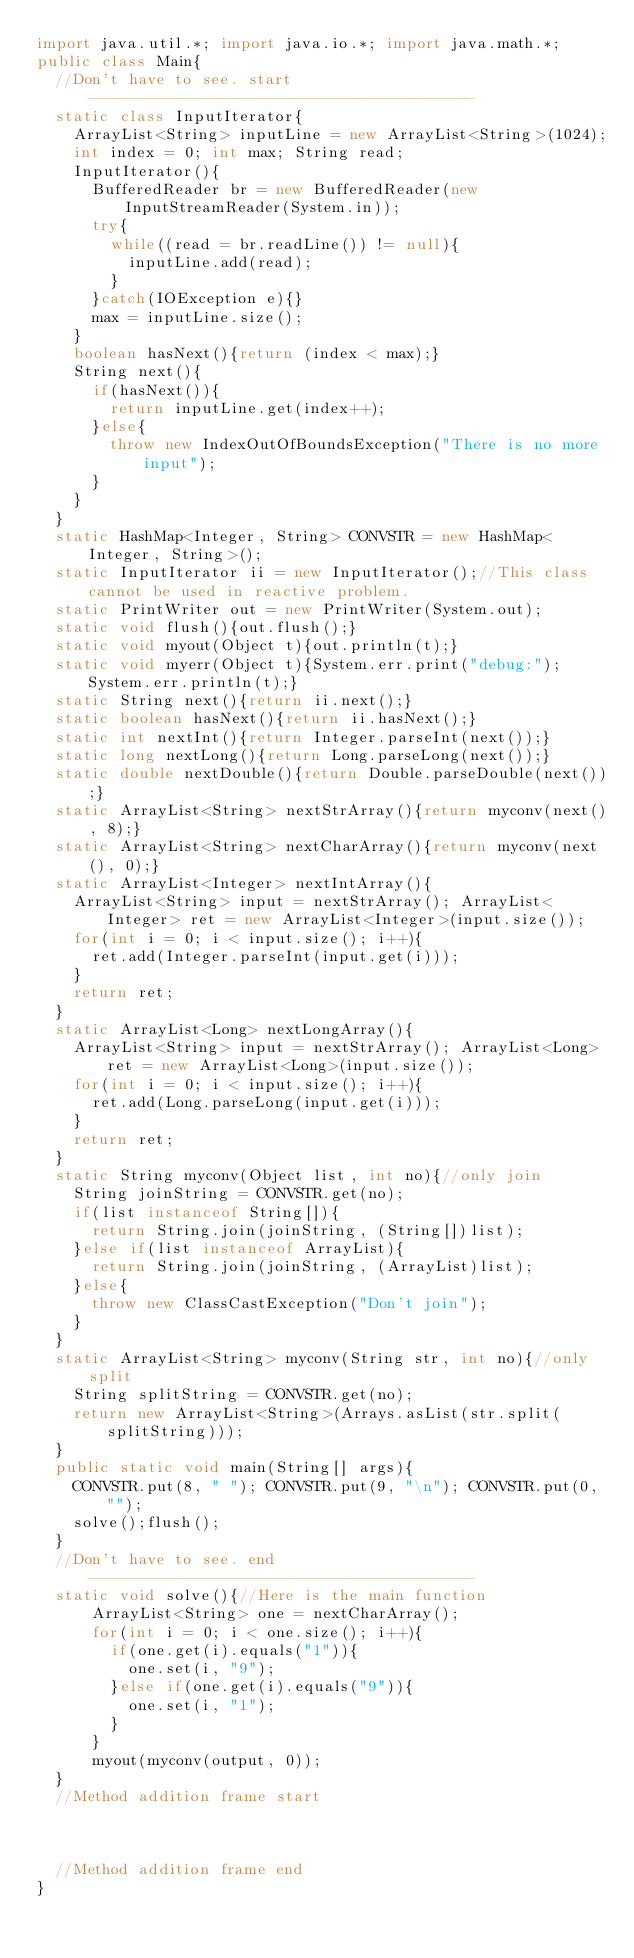<code> <loc_0><loc_0><loc_500><loc_500><_Java_>import java.util.*; import java.io.*; import java.math.*;
public class Main{
	//Don't have to see. start------------------------------------------
	static class InputIterator{
		ArrayList<String> inputLine = new ArrayList<String>(1024);
		int index = 0; int max; String read;
		InputIterator(){
			BufferedReader br = new BufferedReader(new InputStreamReader(System.in));
			try{
				while((read = br.readLine()) != null){
					inputLine.add(read);
				}
			}catch(IOException e){}
			max = inputLine.size();
		}
		boolean hasNext(){return (index < max);}
		String next(){
			if(hasNext()){
				return inputLine.get(index++);
			}else{
				throw new IndexOutOfBoundsException("There is no more input");
			}
		}
	}
	static HashMap<Integer, String> CONVSTR = new HashMap<Integer, String>();
	static InputIterator ii = new InputIterator();//This class cannot be used in reactive problem.
	static PrintWriter out = new PrintWriter(System.out);
	static void flush(){out.flush();}
	static void myout(Object t){out.println(t);}
	static void myerr(Object t){System.err.print("debug:");System.err.println(t);}
	static String next(){return ii.next();}
	static boolean hasNext(){return ii.hasNext();}
	static int nextInt(){return Integer.parseInt(next());}
	static long nextLong(){return Long.parseLong(next());}
	static double nextDouble(){return Double.parseDouble(next());}
	static ArrayList<String> nextStrArray(){return myconv(next(), 8);}
	static ArrayList<String> nextCharArray(){return myconv(next(), 0);}
	static ArrayList<Integer> nextIntArray(){
		ArrayList<String> input = nextStrArray(); ArrayList<Integer> ret = new ArrayList<Integer>(input.size());
		for(int i = 0; i < input.size(); i++){
			ret.add(Integer.parseInt(input.get(i)));
		}
		return ret;
	}
	static ArrayList<Long> nextLongArray(){
		ArrayList<String> input = nextStrArray(); ArrayList<Long> ret = new ArrayList<Long>(input.size());
		for(int i = 0; i < input.size(); i++){
			ret.add(Long.parseLong(input.get(i)));
		}
		return ret;
	}
	static String myconv(Object list, int no){//only join
		String joinString = CONVSTR.get(no);
		if(list instanceof String[]){
			return String.join(joinString, (String[])list);
		}else if(list instanceof ArrayList){
			return String.join(joinString, (ArrayList)list);
		}else{
			throw new ClassCastException("Don't join");
		}
	}
	static ArrayList<String> myconv(String str, int no){//only split
		String splitString = CONVSTR.get(no);
		return new ArrayList<String>(Arrays.asList(str.split(splitString)));
	}
	public static void main(String[] args){
		CONVSTR.put(8, " "); CONVSTR.put(9, "\n"); CONVSTR.put(0, "");
		solve();flush();
	}
	//Don't have to see. end------------------------------------------
	static void solve(){//Here is the main function
      ArrayList<String> one = nextCharArray();
      for(int i = 0; i < one.size(); i++){
        if(one.get(i).equals("1")){
          one.set(i, "9");
        }else if(one.get(i).equals("9")){
          one.set(i, "1");
        }
      }
      myout(myconv(output, 0));
	}
	//Method addition frame start



	//Method addition frame end
}
</code> 